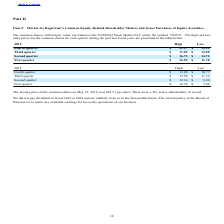According to Agilysys's financial document, What was the closing price of shares on May 21, 2019? According to the financial document, $22.51 per share. The relevant text states: "ng price of the common shares on May 21, 2019, was $22.51 per share. There were 1,561 active shareholders of record...." Also, What were the number of active shareholders on May 21, 2019? According to the financial document, 1,561. The relevant text states: "on May 21, 2019, was $22.51 per share. There were 1,561 active shareholders of record...." Also, What was the High for fourth quarter 2019 per share? According to the financial document, $21.17. The relevant text states: "Fourth quarter $ 21.17 $ 13.92..." Also, can you calculate: What was the increase / (decrease) in the 2019 fourth quarter between low to high? Based on the calculation: 21.17 - 13.92, the result is 7.25. This is based on the information: "Fourth quarter $ 21.17 $ 13.92 Fourth quarter $ 21.17 $ 13.92..." The key data points involved are: 13.92, 21.17. Also, can you calculate: What was the average 2019 third quarter for high and low? To answer this question, I need to perform calculations using the financial data. The calculation is: (17.02 + 13.88) / 2, which equals 15.45. This is based on the information: "Third quarter $ 17.02 $ 13.88 Third quarter $ 17.02 $ 13.88..." The key data points involved are: 13.88, 17.02. Also, can you calculate: What was the increase / (decrease) in the 2019 second quarter between low and high? Based on the calculation: 16.72 - 14.72, the result is 2. This is based on the information: "Second quarter $ 16.72 $ 14.72 Second quarter $ 16.72 $ 14.72..." The key data points involved are: 14.72, 16.72. 